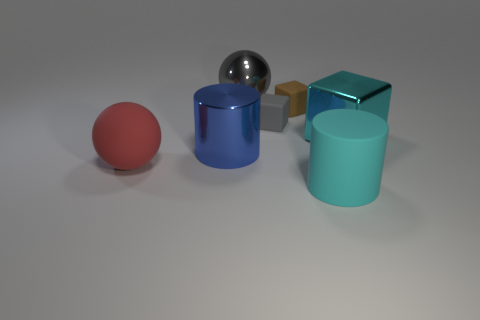There is another metallic thing that is the same shape as the small gray object; what is its size?
Provide a short and direct response. Large. There is a ball that is on the right side of the large red thing; what number of red matte things are behind it?
Provide a succinct answer. 0. The big sphere to the right of the metal thing that is to the left of the big gray metallic thing is what color?
Your answer should be very brief. Gray. What is the object that is both to the left of the metallic ball and on the right side of the large rubber sphere made of?
Your answer should be very brief. Metal. Is there a metal thing of the same shape as the red matte thing?
Your response must be concise. Yes. Is the shape of the large object that is in front of the big red rubber thing the same as  the brown rubber object?
Provide a succinct answer. No. What number of big metal objects are both right of the blue object and left of the large cube?
Your response must be concise. 1. The big cyan thing that is on the right side of the big cyan cylinder has what shape?
Keep it short and to the point. Cube. What number of spheres are made of the same material as the cyan cube?
Your answer should be compact. 1. Do the red rubber thing and the large rubber object that is in front of the red ball have the same shape?
Offer a terse response. No. 